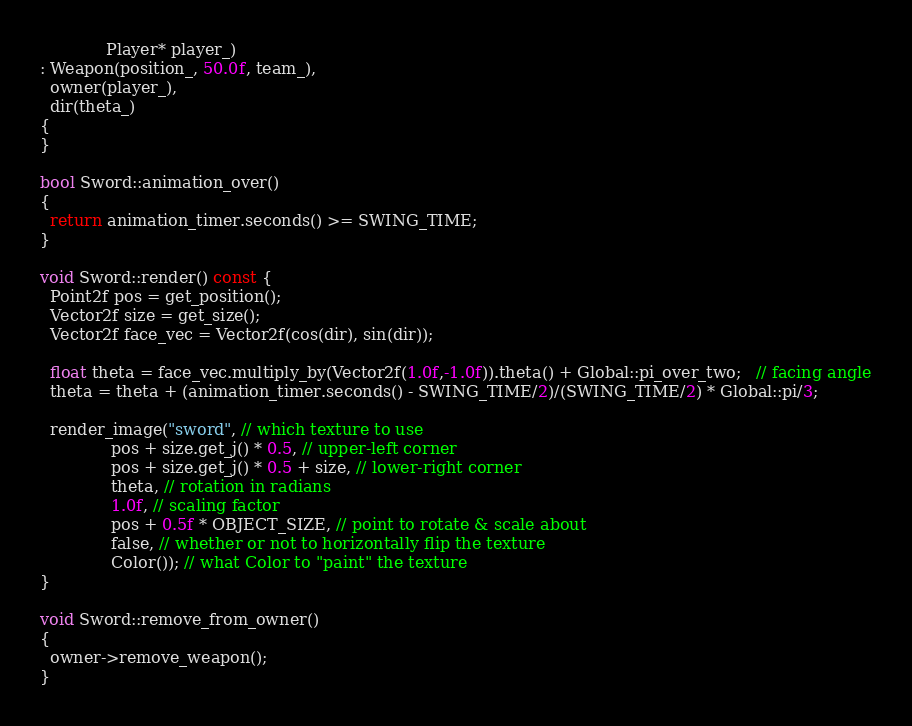Convert code to text. <code><loc_0><loc_0><loc_500><loc_500><_C++_>             Player* player_)
: Weapon(position_, 50.0f, team_),
  owner(player_),
  dir(theta_)
{
}

bool Sword::animation_over()
{
  return animation_timer.seconds() >= SWING_TIME;
}

void Sword::render() const {
  Point2f pos = get_position();
  Vector2f size = get_size();
  Vector2f face_vec = Vector2f(cos(dir), sin(dir));

  float theta = face_vec.multiply_by(Vector2f(1.0f,-1.0f)).theta() + Global::pi_over_two;   // facing angle
  theta = theta + (animation_timer.seconds() - SWING_TIME/2)/(SWING_TIME/2) * Global::pi/3;
  
  render_image("sword", // which texture to use
              pos + size.get_j() * 0.5, // upper-left corner
              pos + size.get_j() * 0.5 + size, // lower-right corner
              theta, // rotation in radians
              1.0f, // scaling factor
              pos + 0.5f * OBJECT_SIZE, // point to rotate & scale about
              false, // whether or not to horizontally flip the texture
              Color()); // what Color to "paint" the texture  
}

void Sword::remove_from_owner()
{
  owner->remove_weapon();
}</code> 